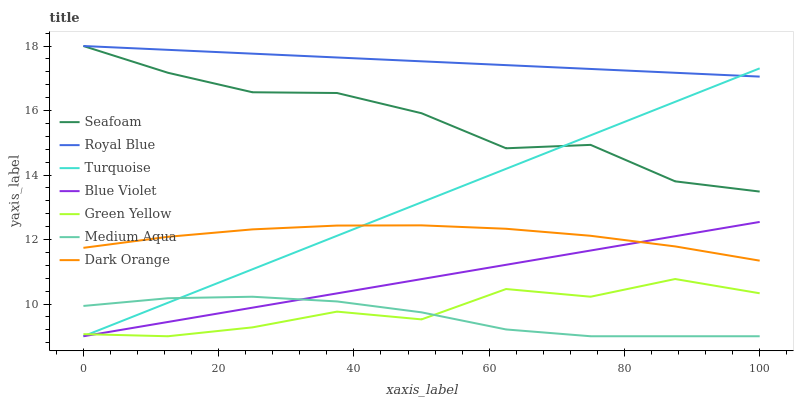Does Medium Aqua have the minimum area under the curve?
Answer yes or no. Yes. Does Royal Blue have the maximum area under the curve?
Answer yes or no. Yes. Does Turquoise have the minimum area under the curve?
Answer yes or no. No. Does Turquoise have the maximum area under the curve?
Answer yes or no. No. Is Turquoise the smoothest?
Answer yes or no. Yes. Is Green Yellow the roughest?
Answer yes or no. Yes. Is Seafoam the smoothest?
Answer yes or no. No. Is Seafoam the roughest?
Answer yes or no. No. Does Turquoise have the lowest value?
Answer yes or no. Yes. Does Seafoam have the lowest value?
Answer yes or no. No. Does Royal Blue have the highest value?
Answer yes or no. Yes. Does Turquoise have the highest value?
Answer yes or no. No. Is Blue Violet less than Seafoam?
Answer yes or no. Yes. Is Seafoam greater than Blue Violet?
Answer yes or no. Yes. Does Turquoise intersect Seafoam?
Answer yes or no. Yes. Is Turquoise less than Seafoam?
Answer yes or no. No. Is Turquoise greater than Seafoam?
Answer yes or no. No. Does Blue Violet intersect Seafoam?
Answer yes or no. No. 